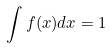Convert formula to latex. <formula><loc_0><loc_0><loc_500><loc_500>\int f ( x ) d x = 1</formula> 